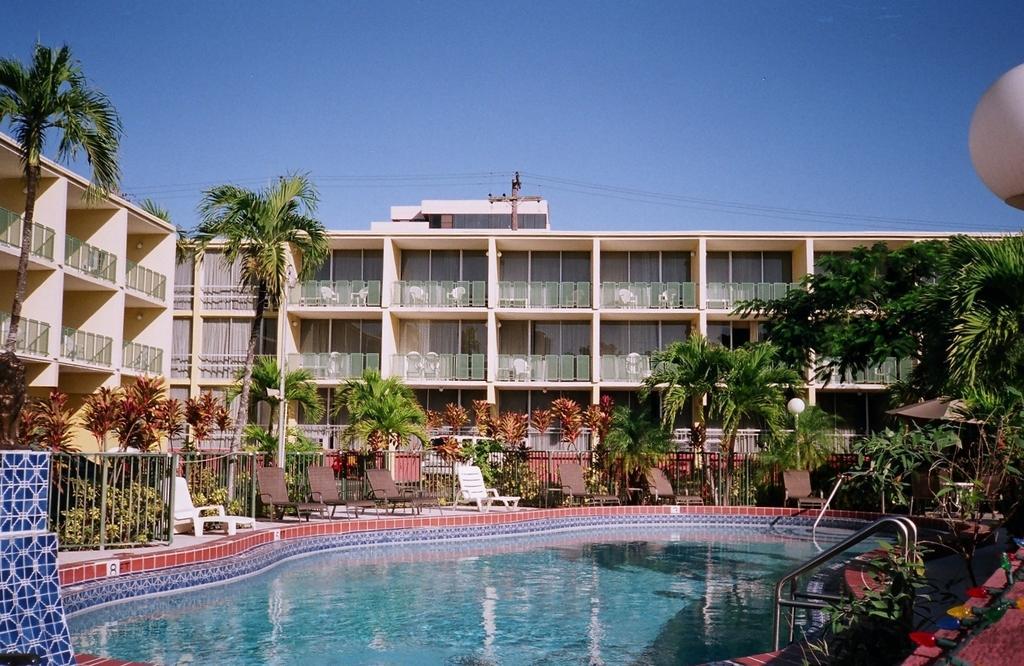Please provide a concise description of this image. In this picture we can see a swimming pool at the bottom, in the background there is a building, we can see some trees, plants, benches, fencing panel and a light in the middle, there is the sky at the top of the picture, we can see glasses of this building. 